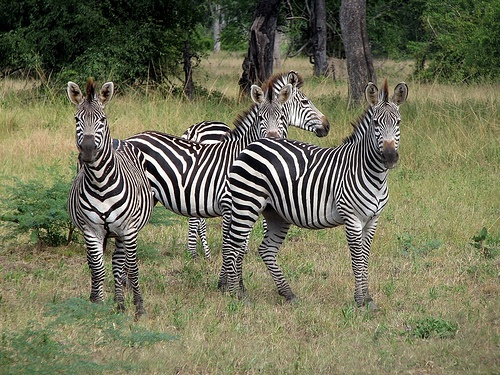Describe the objects in this image and their specific colors. I can see zebra in black, gray, lightgray, and darkgray tones, zebra in black, white, gray, and darkgray tones, and zebra in black, gray, darkgray, and lightgray tones in this image. 